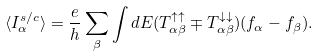Convert formula to latex. <formula><loc_0><loc_0><loc_500><loc_500>\langle I _ { \alpha } ^ { s / c } \rangle = \frac { e } { h } \sum _ { \beta } \int d E ( T _ { \alpha \beta } ^ { \uparrow \uparrow } \mp T _ { \alpha \beta } ^ { \downarrow \downarrow } ) ( f _ { \alpha } - f _ { \beta } ) .</formula> 